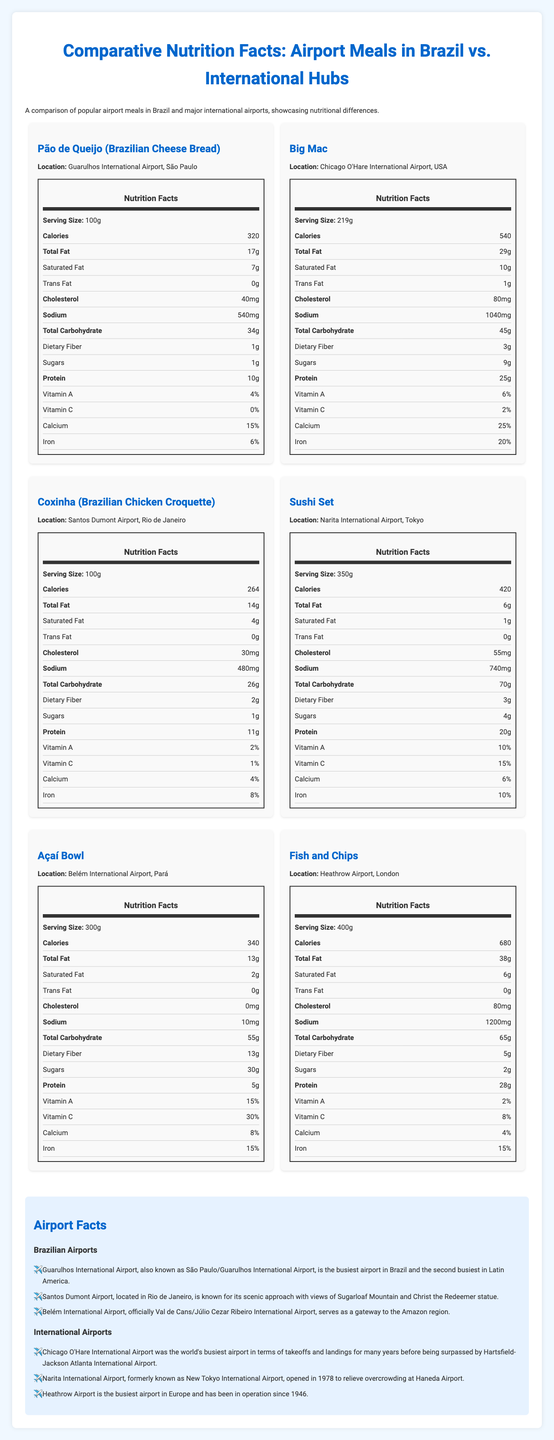what is the serving size of the Pão de Queijo? The serving size information is listed in the nutrition facts section under the meal title "Pão de Queijo."
Answer: 100g which meal has the highest calorie content? The Fish and Chips meal from Heathrow Airport, London, has 680 calories, which is the highest among the meals listed.
Answer: Fish and Chips how much protein does a Big Mac contain? In the nutrition facts section for the Big Mac, it states that the meal contains 25 grams of protein.
Answer: 25g what vitamin has the highest percentage in an Açaí Bowl? The nutrition facts for the Açaí Bowl show that it contains 30% of the daily value for Vitamin C, which is the highest among the vitamins listed for this meal.
Answer: Vitamin C is there any trans fat in a Coxinha from Santos Dumont Airport? The nutrition facts for a Coxinha indicate that it has 0 grams of trans fat.
Answer: No which airport meal has the lowest sodium content? A. Pão de Queijo B. Big Mac C. Açaí Bowl D. Sushi Set The Açaí Bowl has only 10mg of sodium, which is the lowest among the listed options.
Answer: C what is the primary difference in total carbohydrate content between the Pão de Queijo and the Sushi Set? A. Pão de Queijo has more B. Sushi Set has more C. Both have equal content D. Not listed The Sushi Set has 70 grams of total carbohydrates compared to Pão de Queijo's 34 grams.
Answer: B which meal contains the most dietary fiber? i. Coxinha ii. Pão de Queijo iii. Açaí Bowl iv. Fish and Chips The Açaí Bowl has 13 grams of dietary fiber, the highest among the meals listed.
Answer: iii. Açaí Bowl does the Sushi Set from Narita International Airport contain any Vitamin A? The nutrition facts label for the Sushi Set shows that it contains 10% of the daily value of Vitamin A.
Answer: Yes summarize the main idea of the document. The document provides a detailed comparison of nutritional content such as calories, fats, proteins, vitamins, etc., of various meals from airports like Guarulhos, Santos Dumont, Chicago O'Hare, Narita, and Heathrow. It also offers interesting facts about these airports to give additional context.
Answer: The document compares the nutritional facts of popular airport meals in Brazil and major international airports, highlighting differences in nutritional values and includes interesting facts about the airports. how does the sodium content of a Big Mac compare to that of Pão de Queijo? The Big Mac has 1040mg of sodium, which is almost double the 540mg of sodium found in the Pão de Queijo.
Answer: The Big Mac contains significantly more sodium than the Pão de Queijo. which vitamin is not listed for any of the meals? The document does not provide information on all vitamins for each meal, so it is not possible to determine which vitamin is not listed for any meal.
Answer: Cannot be determined 